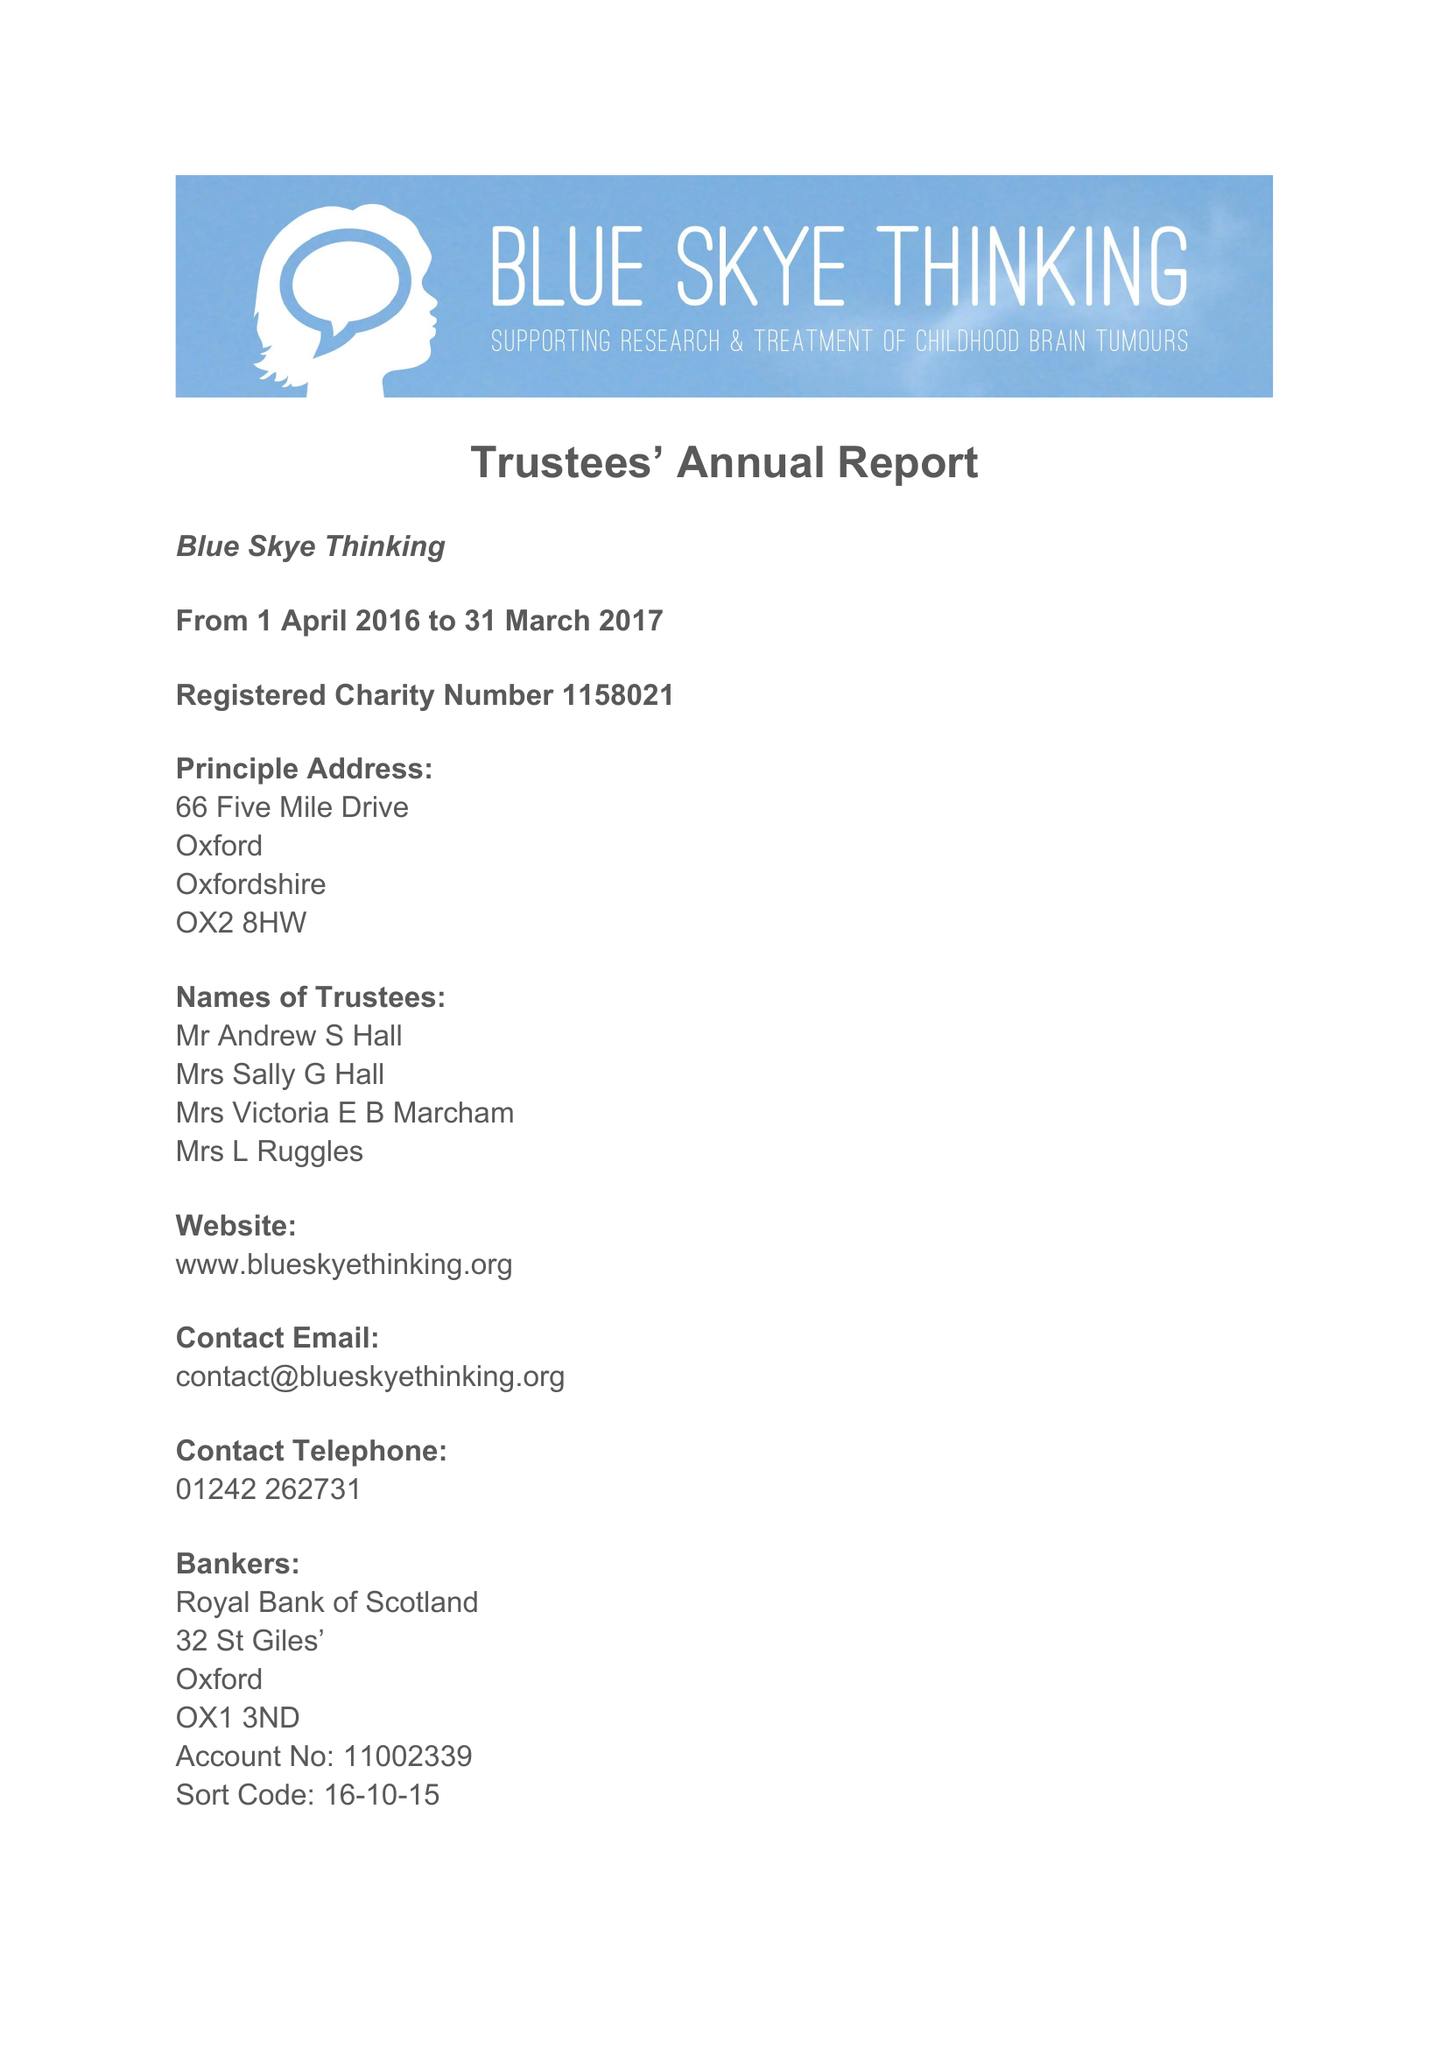What is the value for the address__street_line?
Answer the question using a single word or phrase. 66 FIVE MILE DRIVE 